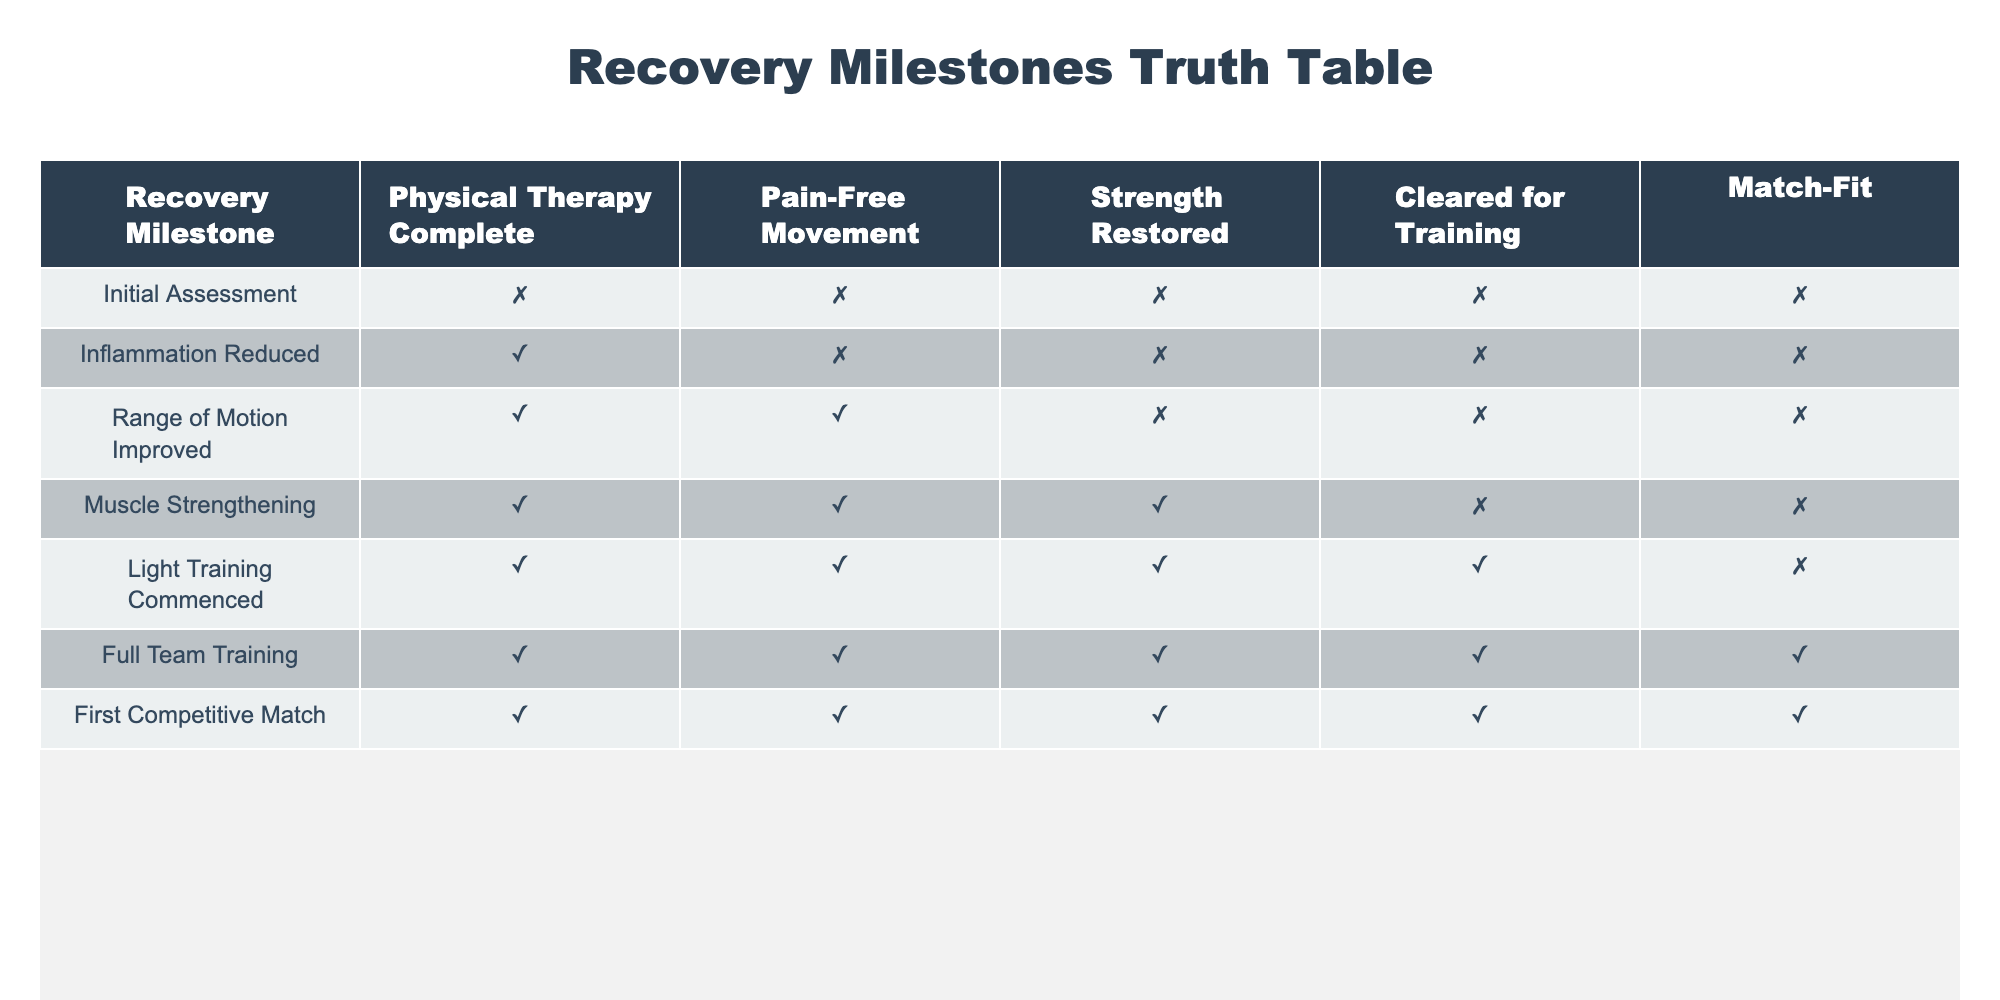What is the last recovery milestone where the individual was not cleared for training? The last recovery milestone without "Cleared for Training" marked as true is "Muscle Strengthening," which shows it as false. "Light Training Commenced" is the next milestone where it is true.
Answer: Muscle Strengthening How many recovery milestones show pain-free movement? By counting the "TRUE" values under "Pain-Free Movement," we find that there are four milestones: "Range of Motion Improved," "Muscle Strengthening," "Light Training Commenced," and "Full Team Training."
Answer: 4 Is inflammation reduced a necessary step before achieving pain-free movement? In the table, "Inflammation Reduced" shows true while "Pain-Free Movement" is false. Thus, it indicates that inflammation can be reduced without achieving pain-free movement.
Answer: No At which recovery milestone does full recovery begin, as indicated by match fitness? The milestone for "Match-Fit" first becomes true is "First Competitive Match." Prior to that, "Light Training Commenced," and "Full Team Training" indicates readiness but not match readiness.
Answer: First Competitive Match What is the only recovery milestone where strength is restored but the athlete is not cleared for training? From the data, the milestone "Muscle Strengthening" shows strength restored as true but "Cleared for Training" as false.
Answer: Muscle Strengthening Which recovery milestones have all values as true? The "Full Team Training" and "First Competitive Match" milestones have all indicators as true.
Answer: Full Team Training, First Competitive Match What are the recovery milestones that lead to being cleared for training? The milestones leading to being cleared for training start from "Muscle Strengthening" to "First Competitive Match," with "Light Training Commenced" also being crucial in the process.
Answer: Muscle Strengthening, Light Training Commenced, Full Team Training Was pain-free movement achieved after the range of motion was improved? Yes, according to the table, after "Range of Motion Improved," pain-free movement was achieved at the next milestone "Muscle Strengthening."
Answer: Yes How many recovery milestones were successful in all five categories? The table shows that only the "Full Team Training" and "First Competitive Match" marked true across all five categories, indicating complete recovery.
Answer: 2 